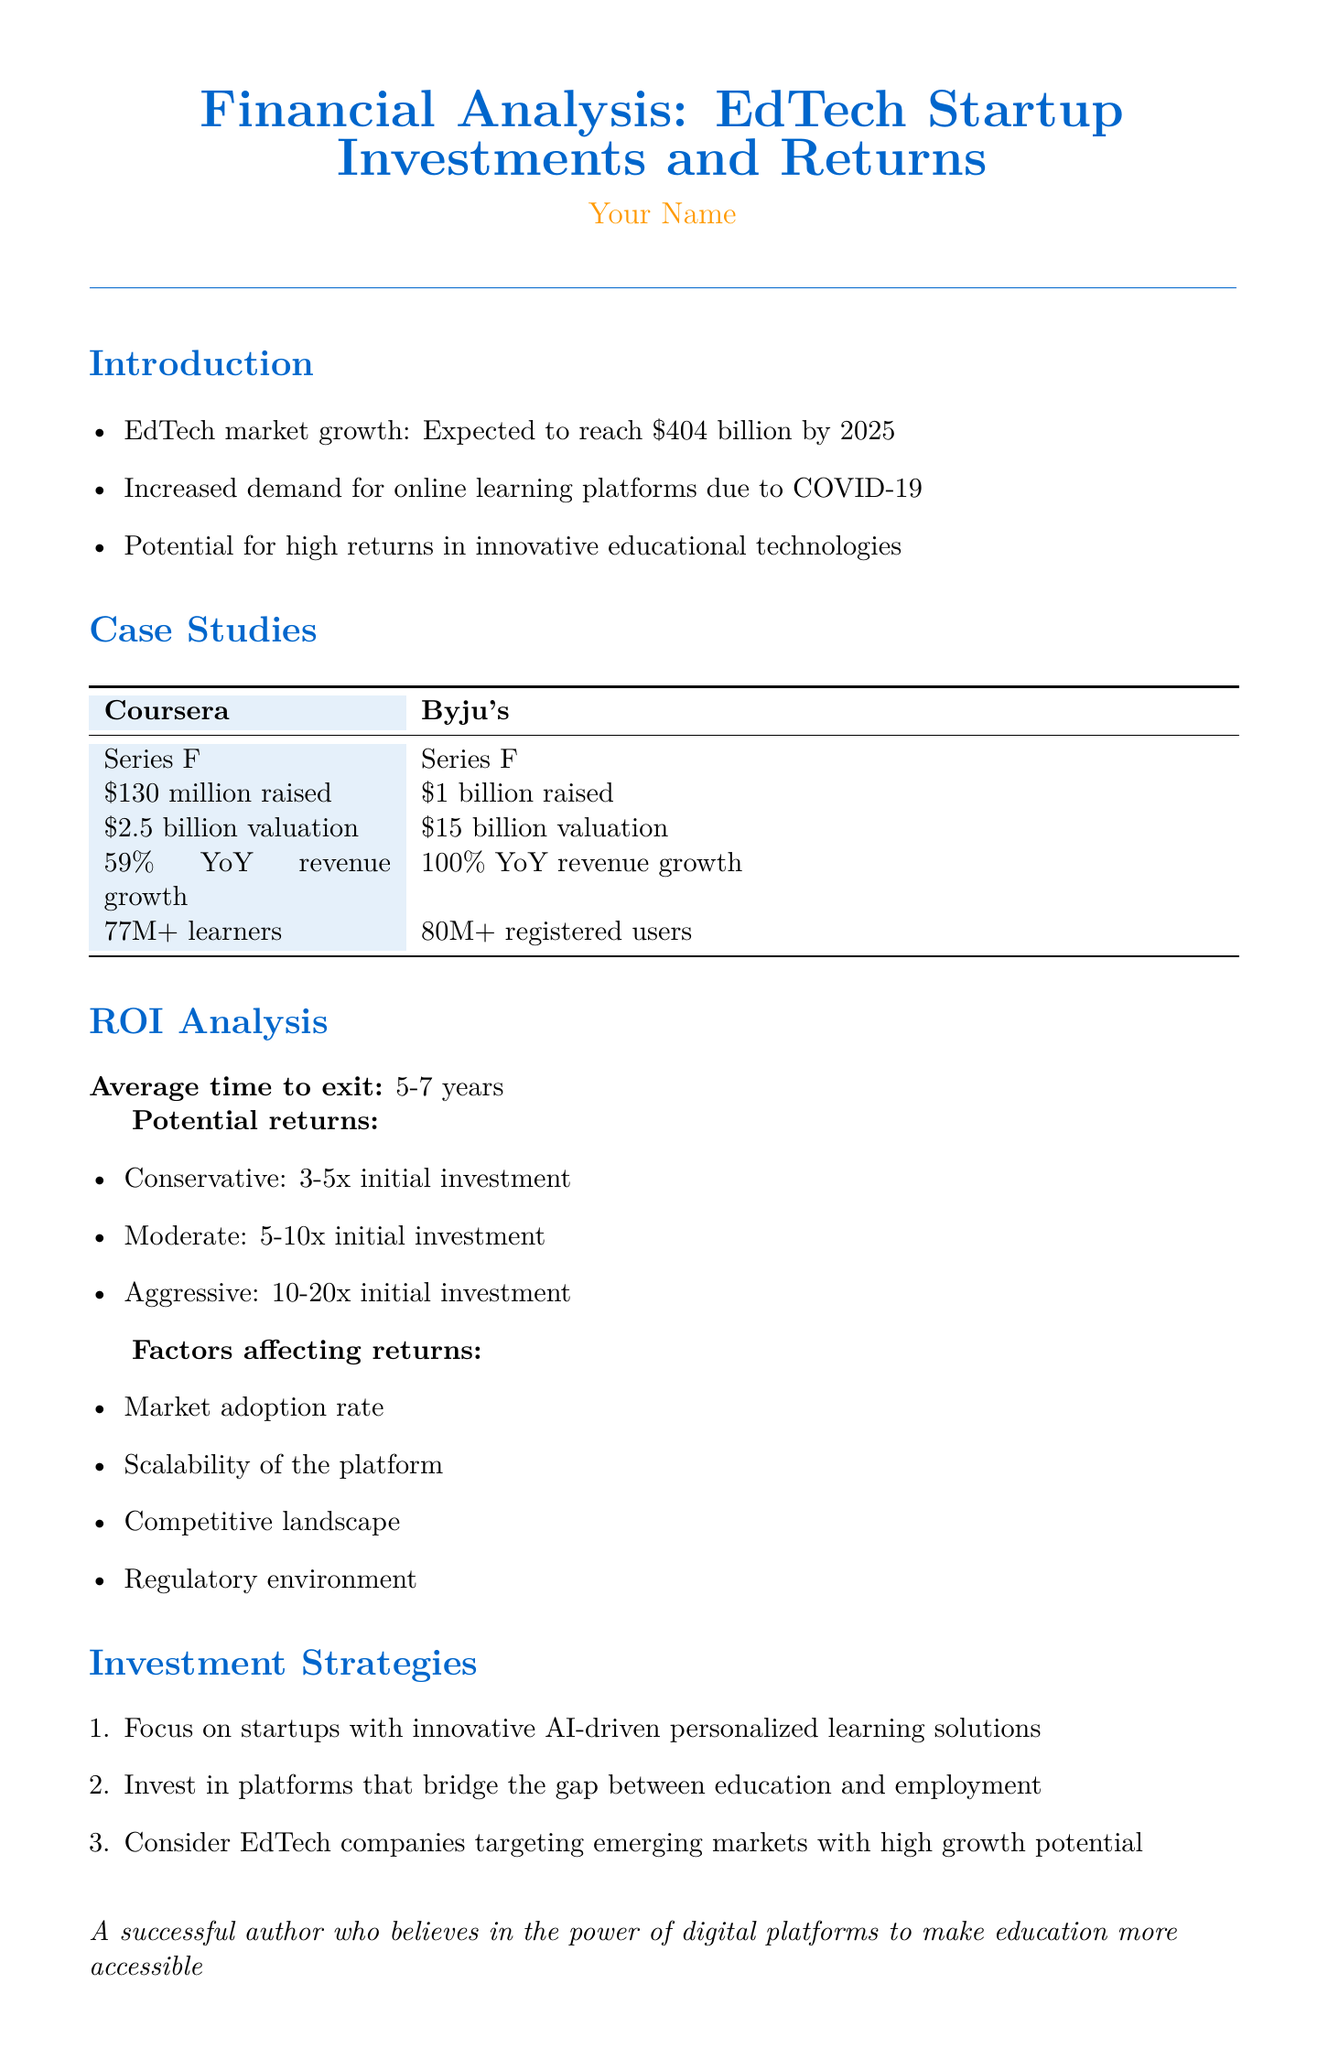What is the expected EdTech market growth by 2025? The document states that the EdTech market is expected to reach $404 billion by 2025.
Answer: $404 billion How much did Byju's raise in their latest funding round? The document specifies that Byju's raised $1 billion in their Series F investment round.
Answer: $1 billion What is the average time to exit for EdTech investments? The average time to exit mentioned in the document is 5-7 years.
Answer: 5-7 years What is the aggressive potential return on investment? The document lists the aggressive potential return as 10-20x the initial investment.
Answer: 10-20x initial investment Which company has a user base of over 77 million learners? According to the document, Coursera has a user base of over 77 million learners.
Answer: Coursera What percentage of revenue growth did Byju's achieve year-over-year? The document indicates that Byju's achieved a 100% year-over-year revenue growth.
Answer: 100% What is one of the investment strategies mentioned in the report? The document mentions focusing on startups with innovative AI-driven personalized learning solutions as one investment strategy.
Answer: AI-driven personalized learning solutions What are the factors affecting returns mentioned in the document? The document lists market adoption rate, scalability of the platform, competitive landscape, and regulatory environment as factors affecting returns.
Answer: Market adoption rate, scalability, competitive landscape, regulatory environment What is the main goal of investing in education technology according to the conclusion? The conclusion emphasizes that investing in education technology aligns with the goal of improving access to quality education globally.
Answer: Improving access to quality education globally 